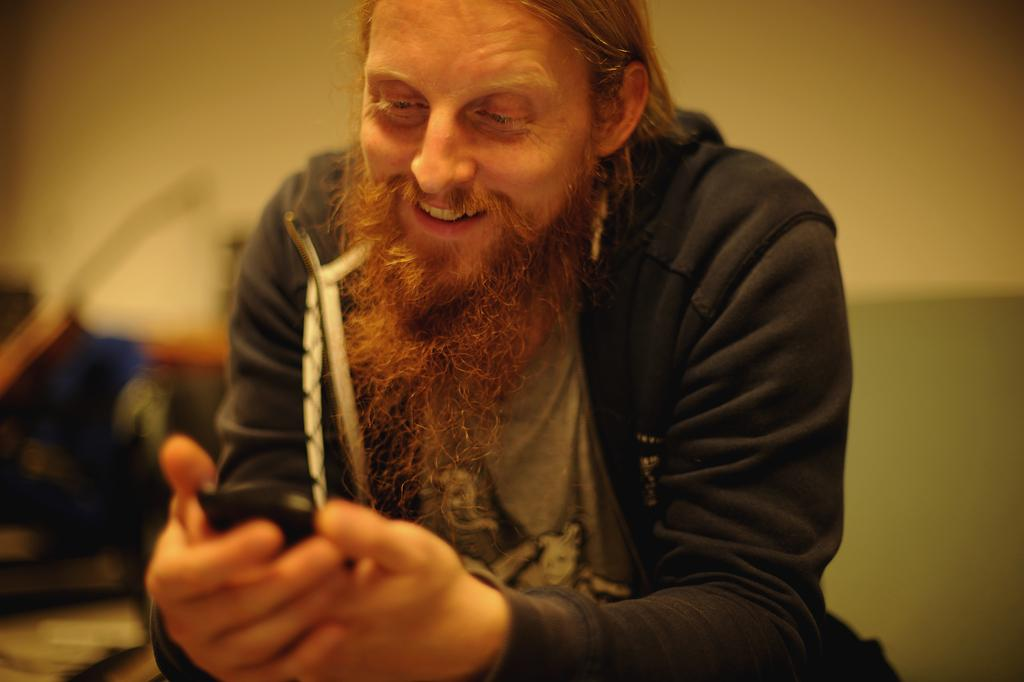What is the man in the image doing? The man is sitting in the image. What is the man holding in his hands? The man is holding a mobile in his hands. Can you describe the person sitting in the background of the image? There is a person sitting in the background of the image, but no specific details are provided. What can be seen in the background of the image? There is a wall visible in the background of the image. What is the man thinking about in the image? There is no information provided about the man's thoughts in the image. What place is the image taken in? The provided facts do not give any information about the location or place where the image was taken. 